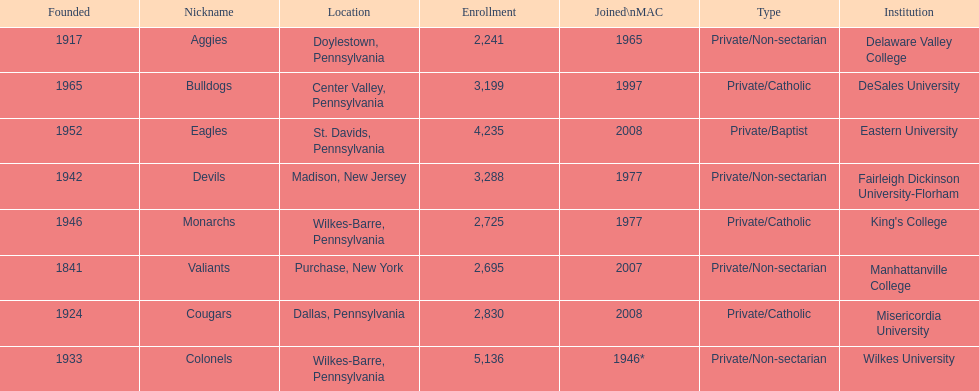What is the enrollment number of misericordia university? 2,830. 